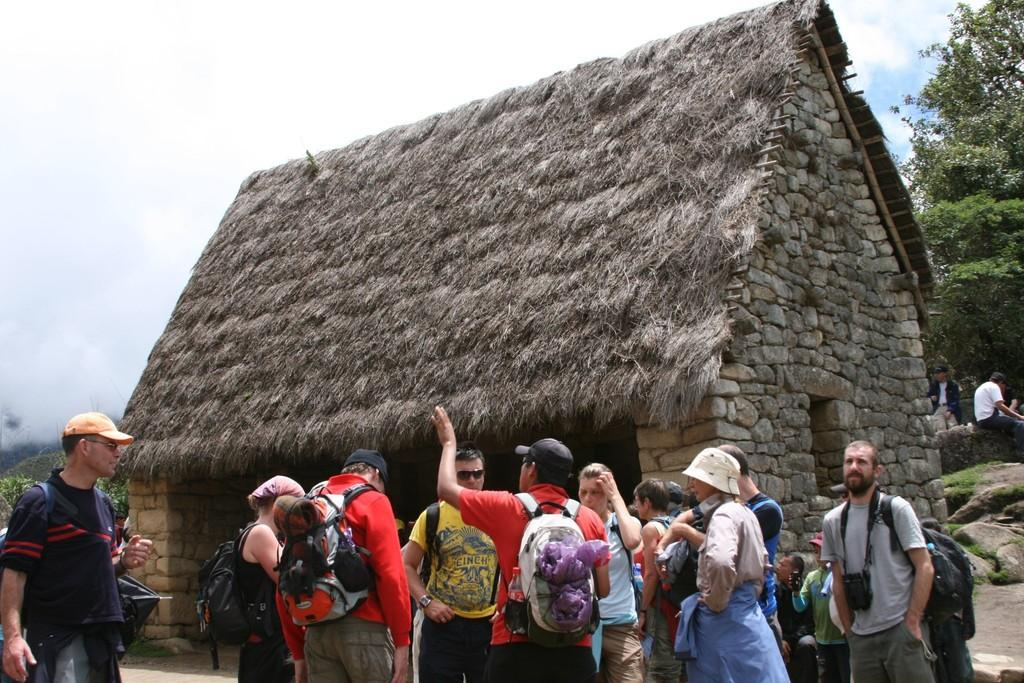What is the main structure in the center of the image? There is a cottage in the center of the image. Who or what can be seen at the bottom of the image? There are people at the bottom of the image. What type of vegetation is visible in the background? There are trees in the background. What else can be seen in the background of the image? The sky is visible in the background. How many pears are being pushed by the people in the image? There are no pears present in the image, and therefore no such activity can be observed. 